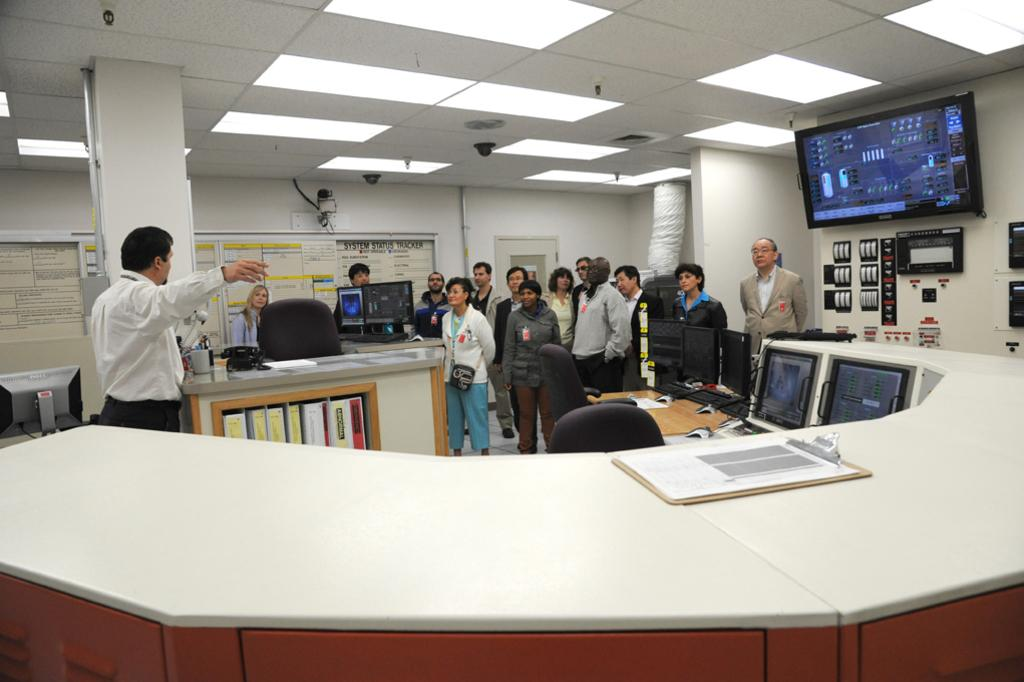What is the main subject of the image? The main subject of the image is a group of people standing. What else can be seen in the image besides the people? There is a screen, a notepad on a table, and a chair in the image. How many pets are visible in the image? There are no pets present in the image. What type of tooth is being used by the people in the image? There is no tooth visible in the image, as people typically do not use teeth in this context. 